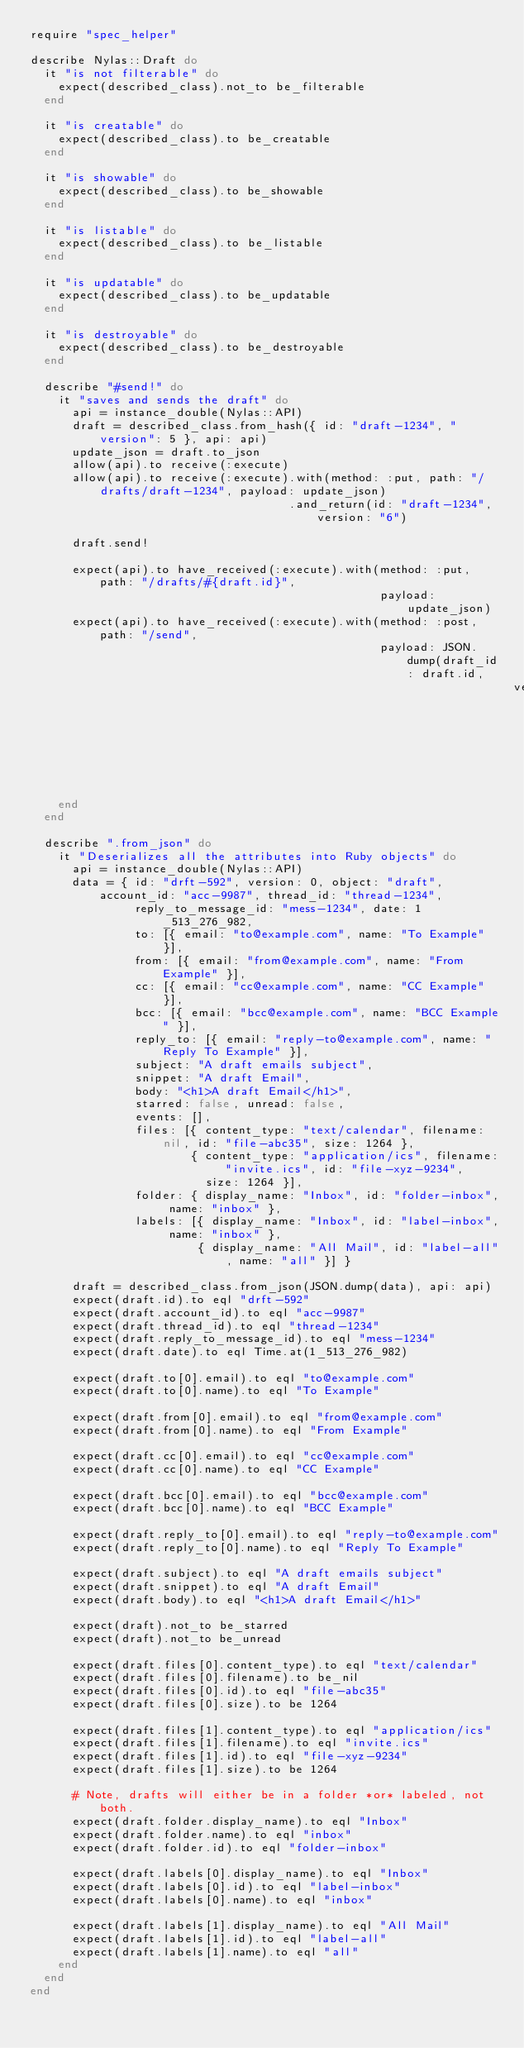Convert code to text. <code><loc_0><loc_0><loc_500><loc_500><_Ruby_>require "spec_helper"

describe Nylas::Draft do
  it "is not filterable" do
    expect(described_class).not_to be_filterable
  end

  it "is creatable" do
    expect(described_class).to be_creatable
  end

  it "is showable" do
    expect(described_class).to be_showable
  end

  it "is listable" do
    expect(described_class).to be_listable
  end

  it "is updatable" do
    expect(described_class).to be_updatable
  end

  it "is destroyable" do
    expect(described_class).to be_destroyable
  end

  describe "#send!" do
    it "saves and sends the draft" do
      api = instance_double(Nylas::API)
      draft = described_class.from_hash({ id: "draft-1234", "version": 5 }, api: api)
      update_json = draft.to_json
      allow(api).to receive(:execute)
      allow(api).to receive(:execute).with(method: :put, path: "/drafts/draft-1234", payload: update_json)
                                     .and_return(id: "draft-1234", version: "6")

      draft.send!

      expect(api).to have_received(:execute).with(method: :put, path: "/drafts/#{draft.id}",
                                                  payload: update_json)
      expect(api).to have_received(:execute).with(method: :post, path: "/send",
                                                  payload: JSON.dump(draft_id: draft.id,
                                                                     version: draft.version))
    end
  end

  describe ".from_json" do
    it "Deserializes all the attributes into Ruby objects" do
      api = instance_double(Nylas::API)
      data = { id: "drft-592", version: 0, object: "draft", account_id: "acc-9987", thread_id: "thread-1234",
               reply_to_message_id: "mess-1234", date: 1_513_276_982,
               to: [{ email: "to@example.com", name: "To Example" }],
               from: [{ email: "from@example.com", name: "From Example" }],
               cc: [{ email: "cc@example.com", name: "CC Example" }],
               bcc: [{ email: "bcc@example.com", name: "BCC Example" }],
               reply_to: [{ email: "reply-to@example.com", name: "Reply To Example" }],
               subject: "A draft emails subject",
               snippet: "A draft Email",
               body: "<h1>A draft Email</h1>",
               starred: false, unread: false,
               events: [],
               files: [{ content_type: "text/calendar", filename: nil, id: "file-abc35", size: 1264 },
                       { content_type: "application/ics", filename: "invite.ics", id: "file-xyz-9234",
                         size: 1264 }],
               folder: { display_name: "Inbox", id: "folder-inbox", name: "inbox" },
               labels: [{ display_name: "Inbox", id: "label-inbox", name: "inbox" },
                        { display_name: "All Mail", id: "label-all", name: "all" }] }

      draft = described_class.from_json(JSON.dump(data), api: api)
      expect(draft.id).to eql "drft-592"
      expect(draft.account_id).to eql "acc-9987"
      expect(draft.thread_id).to eql "thread-1234"
      expect(draft.reply_to_message_id).to eql "mess-1234"
      expect(draft.date).to eql Time.at(1_513_276_982)

      expect(draft.to[0].email).to eql "to@example.com"
      expect(draft.to[0].name).to eql "To Example"

      expect(draft.from[0].email).to eql "from@example.com"
      expect(draft.from[0].name).to eql "From Example"

      expect(draft.cc[0].email).to eql "cc@example.com"
      expect(draft.cc[0].name).to eql "CC Example"

      expect(draft.bcc[0].email).to eql "bcc@example.com"
      expect(draft.bcc[0].name).to eql "BCC Example"

      expect(draft.reply_to[0].email).to eql "reply-to@example.com"
      expect(draft.reply_to[0].name).to eql "Reply To Example"

      expect(draft.subject).to eql "A draft emails subject"
      expect(draft.snippet).to eql "A draft Email"
      expect(draft.body).to eql "<h1>A draft Email</h1>"

      expect(draft).not_to be_starred
      expect(draft).not_to be_unread

      expect(draft.files[0].content_type).to eql "text/calendar"
      expect(draft.files[0].filename).to be_nil
      expect(draft.files[0].id).to eql "file-abc35"
      expect(draft.files[0].size).to be 1264

      expect(draft.files[1].content_type).to eql "application/ics"
      expect(draft.files[1].filename).to eql "invite.ics"
      expect(draft.files[1].id).to eql "file-xyz-9234"
      expect(draft.files[1].size).to be 1264

      # Note, drafts will either be in a folder *or* labeled, not both.
      expect(draft.folder.display_name).to eql "Inbox"
      expect(draft.folder.name).to eql "inbox"
      expect(draft.folder.id).to eql "folder-inbox"

      expect(draft.labels[0].display_name).to eql "Inbox"
      expect(draft.labels[0].id).to eql "label-inbox"
      expect(draft.labels[0].name).to eql "inbox"

      expect(draft.labels[1].display_name).to eql "All Mail"
      expect(draft.labels[1].id).to eql "label-all"
      expect(draft.labels[1].name).to eql "all"
    end
  end
end
</code> 